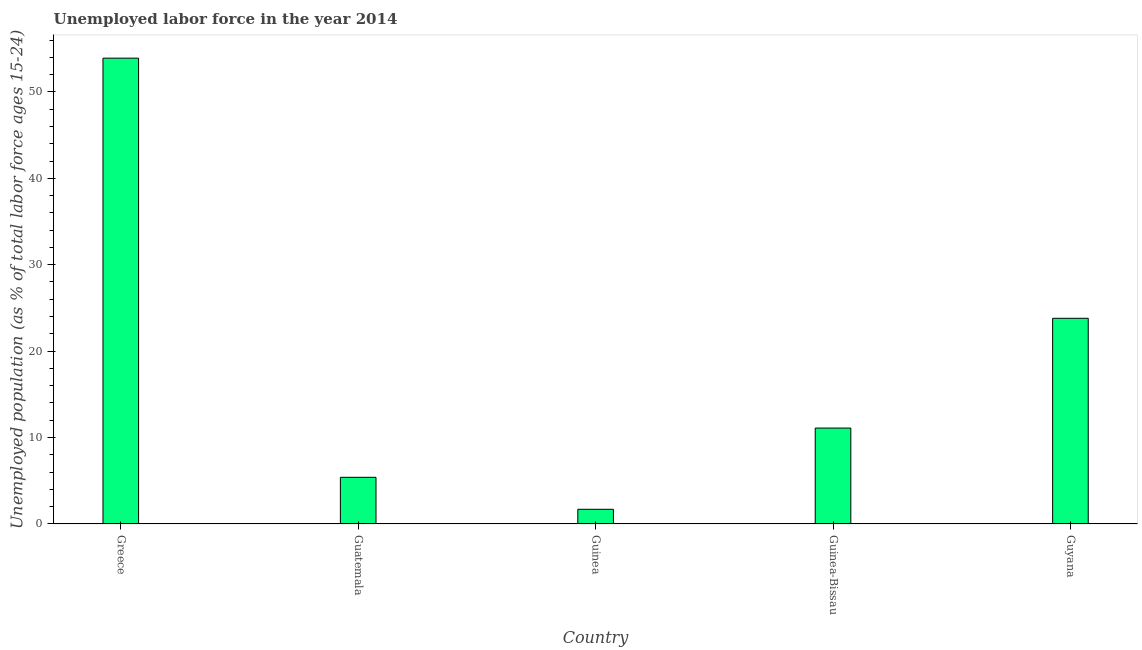Does the graph contain any zero values?
Keep it short and to the point. No. Does the graph contain grids?
Give a very brief answer. No. What is the title of the graph?
Provide a short and direct response. Unemployed labor force in the year 2014. What is the label or title of the Y-axis?
Your answer should be very brief. Unemployed population (as % of total labor force ages 15-24). What is the total unemployed youth population in Greece?
Provide a short and direct response. 53.9. Across all countries, what is the maximum total unemployed youth population?
Provide a succinct answer. 53.9. Across all countries, what is the minimum total unemployed youth population?
Make the answer very short. 1.7. In which country was the total unemployed youth population minimum?
Your answer should be compact. Guinea. What is the sum of the total unemployed youth population?
Your response must be concise. 95.9. What is the difference between the total unemployed youth population in Guatemala and Guyana?
Your response must be concise. -18.4. What is the average total unemployed youth population per country?
Provide a short and direct response. 19.18. What is the median total unemployed youth population?
Give a very brief answer. 11.1. In how many countries, is the total unemployed youth population greater than 26 %?
Provide a succinct answer. 1. What is the ratio of the total unemployed youth population in Guatemala to that in Guyana?
Your answer should be very brief. 0.23. What is the difference between the highest and the second highest total unemployed youth population?
Make the answer very short. 30.1. Is the sum of the total unemployed youth population in Guatemala and Guyana greater than the maximum total unemployed youth population across all countries?
Make the answer very short. No. What is the difference between the highest and the lowest total unemployed youth population?
Your answer should be compact. 52.2. In how many countries, is the total unemployed youth population greater than the average total unemployed youth population taken over all countries?
Offer a very short reply. 2. How many bars are there?
Keep it short and to the point. 5. What is the Unemployed population (as % of total labor force ages 15-24) in Greece?
Ensure brevity in your answer.  53.9. What is the Unemployed population (as % of total labor force ages 15-24) in Guatemala?
Your response must be concise. 5.4. What is the Unemployed population (as % of total labor force ages 15-24) of Guinea?
Offer a terse response. 1.7. What is the Unemployed population (as % of total labor force ages 15-24) of Guinea-Bissau?
Your answer should be very brief. 11.1. What is the Unemployed population (as % of total labor force ages 15-24) of Guyana?
Provide a succinct answer. 23.8. What is the difference between the Unemployed population (as % of total labor force ages 15-24) in Greece and Guatemala?
Offer a very short reply. 48.5. What is the difference between the Unemployed population (as % of total labor force ages 15-24) in Greece and Guinea?
Offer a terse response. 52.2. What is the difference between the Unemployed population (as % of total labor force ages 15-24) in Greece and Guinea-Bissau?
Your answer should be compact. 42.8. What is the difference between the Unemployed population (as % of total labor force ages 15-24) in Greece and Guyana?
Offer a very short reply. 30.1. What is the difference between the Unemployed population (as % of total labor force ages 15-24) in Guatemala and Guinea-Bissau?
Your response must be concise. -5.7. What is the difference between the Unemployed population (as % of total labor force ages 15-24) in Guatemala and Guyana?
Give a very brief answer. -18.4. What is the difference between the Unemployed population (as % of total labor force ages 15-24) in Guinea and Guinea-Bissau?
Offer a very short reply. -9.4. What is the difference between the Unemployed population (as % of total labor force ages 15-24) in Guinea and Guyana?
Your answer should be very brief. -22.1. What is the ratio of the Unemployed population (as % of total labor force ages 15-24) in Greece to that in Guatemala?
Provide a short and direct response. 9.98. What is the ratio of the Unemployed population (as % of total labor force ages 15-24) in Greece to that in Guinea?
Provide a succinct answer. 31.71. What is the ratio of the Unemployed population (as % of total labor force ages 15-24) in Greece to that in Guinea-Bissau?
Your answer should be very brief. 4.86. What is the ratio of the Unemployed population (as % of total labor force ages 15-24) in Greece to that in Guyana?
Provide a succinct answer. 2.27. What is the ratio of the Unemployed population (as % of total labor force ages 15-24) in Guatemala to that in Guinea?
Your answer should be compact. 3.18. What is the ratio of the Unemployed population (as % of total labor force ages 15-24) in Guatemala to that in Guinea-Bissau?
Your answer should be compact. 0.49. What is the ratio of the Unemployed population (as % of total labor force ages 15-24) in Guatemala to that in Guyana?
Your answer should be compact. 0.23. What is the ratio of the Unemployed population (as % of total labor force ages 15-24) in Guinea to that in Guinea-Bissau?
Make the answer very short. 0.15. What is the ratio of the Unemployed population (as % of total labor force ages 15-24) in Guinea to that in Guyana?
Offer a terse response. 0.07. What is the ratio of the Unemployed population (as % of total labor force ages 15-24) in Guinea-Bissau to that in Guyana?
Keep it short and to the point. 0.47. 